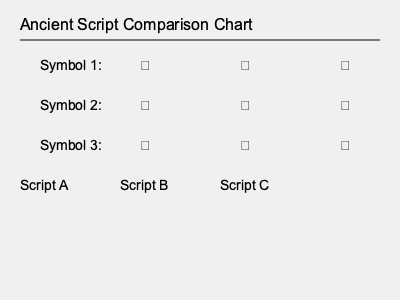Based on the ancient script comparison chart, which symbol in Script C corresponds to Symbol 2 in Script A? Please provide the answer using the symbolic representation shown in the chart. To solve this question, we need to follow these steps:

1. Identify Symbol 2 in Script A:
   - Looking at the second row of the chart, we see that Symbol 2 for Script A is 󰀃.

2. Trace the evolution of this symbol across the scripts:
   - In Script A: 󰀃
   - In Script B: 󰀄
   - In Script C: 󰀅

3. Recognize the pattern:
   - We can observe that the symbol evolves from left to right across the scripts.
   - The corresponding symbol in each script is found in the same row.

4. Identify the answer:
   - The symbol in Script C that corresponds to Symbol 2 in Script A is 󰀅.

This method of comparison is fundamental in deciphering ancient writing systems, as it allows researchers to trace the evolution of symbols across different scripts and time periods.
Answer: 󰀅 